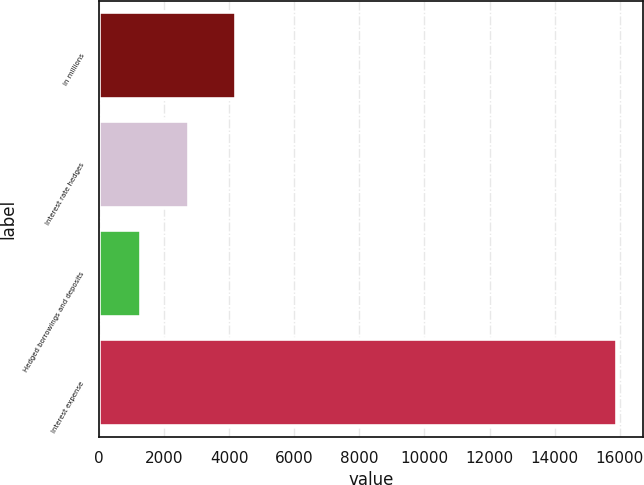Convert chart to OTSL. <chart><loc_0><loc_0><loc_500><loc_500><bar_chart><fcel>in millions<fcel>Interest rate hedges<fcel>Hedged borrowings and deposits<fcel>Interest expense<nl><fcel>4218.4<fcel>2756.7<fcel>1295<fcel>15912<nl></chart> 